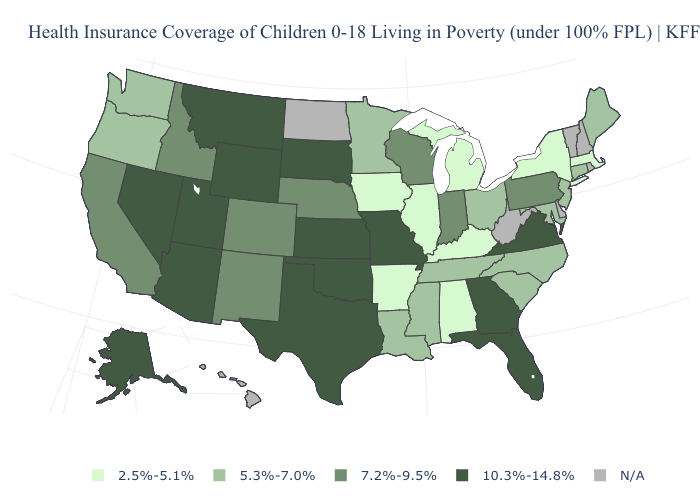What is the value of Wyoming?
Quick response, please. 10.3%-14.8%. What is the value of Tennessee?
Be succinct. 5.3%-7.0%. What is the lowest value in the USA?
Concise answer only. 2.5%-5.1%. Which states have the lowest value in the West?
Quick response, please. Oregon, Washington. What is the value of Texas?
Quick response, please. 10.3%-14.8%. Name the states that have a value in the range 2.5%-5.1%?
Short answer required. Alabama, Arkansas, Illinois, Iowa, Kentucky, Massachusetts, Michigan, New York. What is the highest value in the USA?
Be succinct. 10.3%-14.8%. Name the states that have a value in the range 7.2%-9.5%?
Write a very short answer. California, Colorado, Idaho, Indiana, Nebraska, New Mexico, Pennsylvania, Wisconsin. Among the states that border Rhode Island , which have the highest value?
Be succinct. Connecticut. Name the states that have a value in the range N/A?
Keep it brief. Delaware, Hawaii, New Hampshire, North Dakota, Rhode Island, Vermont, West Virginia. Name the states that have a value in the range N/A?
Short answer required. Delaware, Hawaii, New Hampshire, North Dakota, Rhode Island, Vermont, West Virginia. What is the value of Wisconsin?
Be succinct. 7.2%-9.5%. 